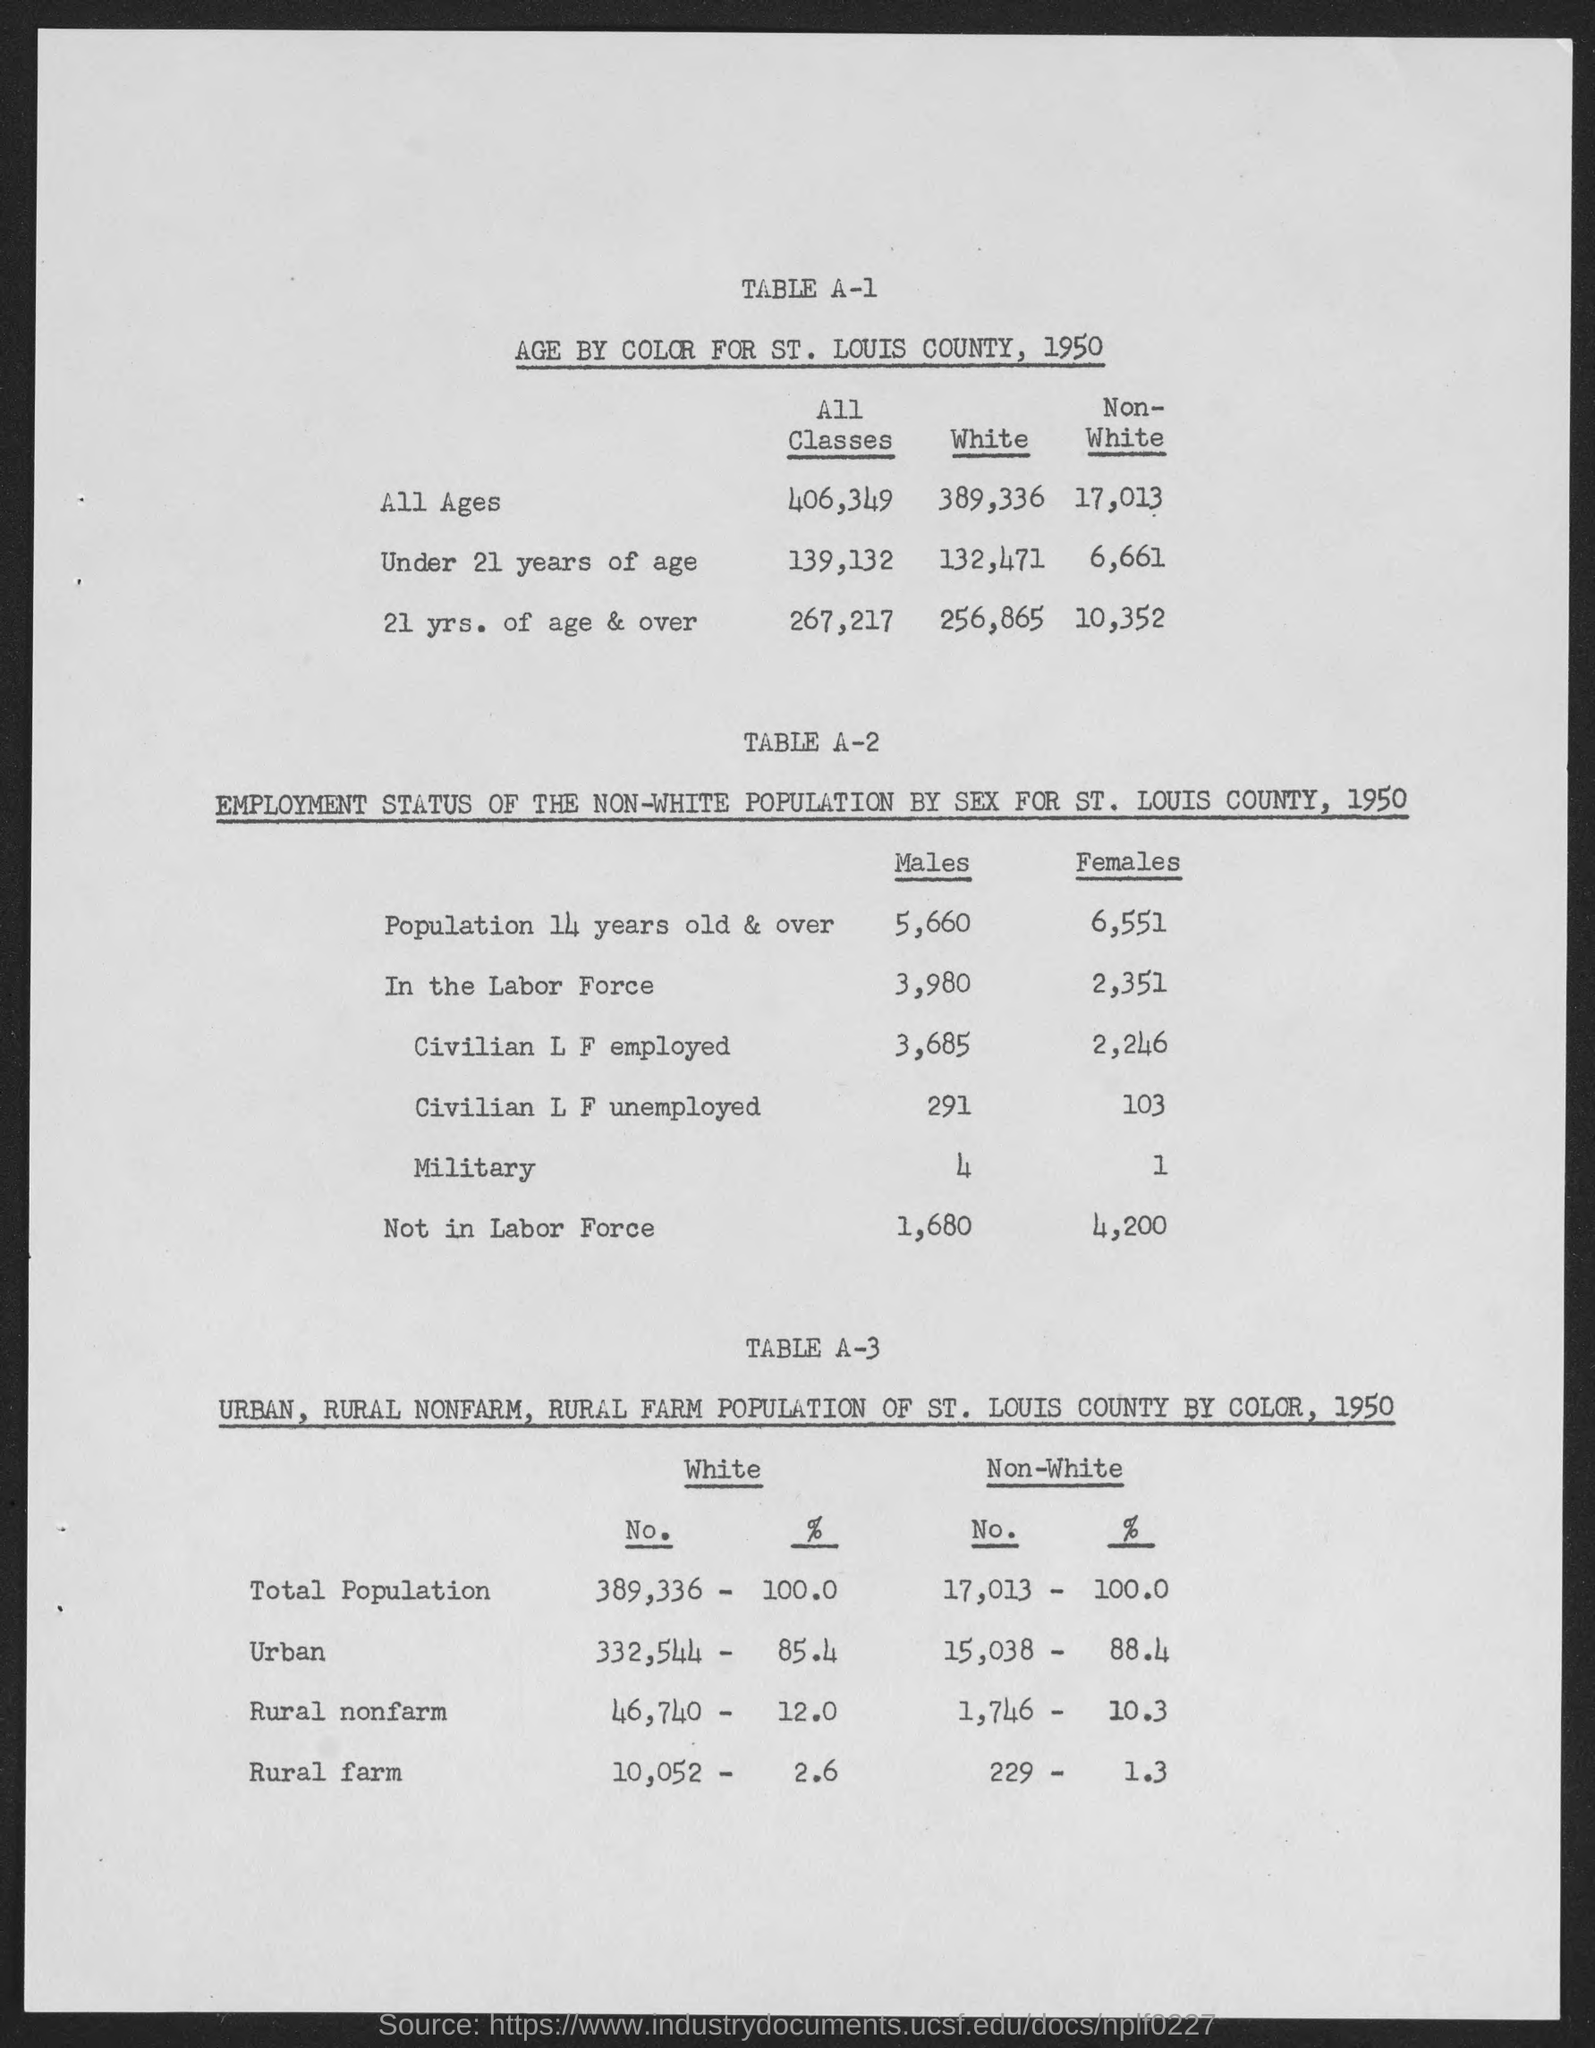What is the age by color for St. Louis county, 1950 for all ages for white?
 389,336 